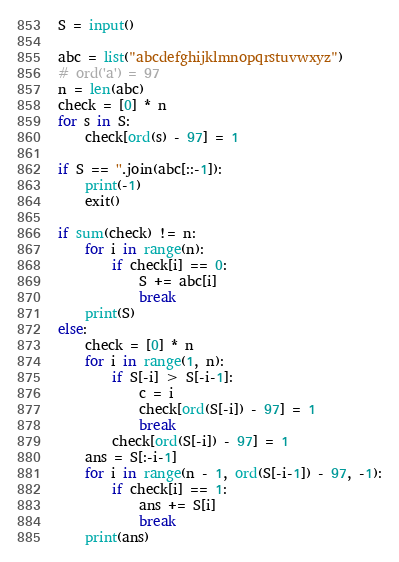Convert code to text. <code><loc_0><loc_0><loc_500><loc_500><_Python_>S = input()

abc = list("abcdefghijklmnopqrstuvwxyz")
# ord('a') = 97
n = len(abc)
check = [0] * n
for s in S:
    check[ord(s) - 97] = 1

if S == ''.join(abc[::-1]):
    print(-1)
    exit()

if sum(check) != n:
    for i in range(n):
        if check[i] == 0:
            S += abc[i]
            break
    print(S)
else:
    check = [0] * n
    for i in range(1, n):
        if S[-i] > S[-i-1]:
            c = i
            check[ord(S[-i]) - 97] = 1
            break
        check[ord(S[-i]) - 97] = 1
    ans = S[:-i-1]
    for i in range(n - 1, ord(S[-i-1]) - 97, -1):
        if check[i] == 1:
            ans += S[i]
            break
    print(ans)
</code> 